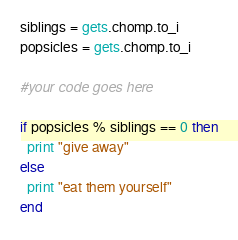Convert code to text. <code><loc_0><loc_0><loc_500><loc_500><_Ruby_>siblings = gets.chomp.to_i
popsicles = gets.chomp.to_i

#your code goes here

if popsicles % siblings == 0 then
  print "give away"
else
  print "eat them yourself"
end
</code> 